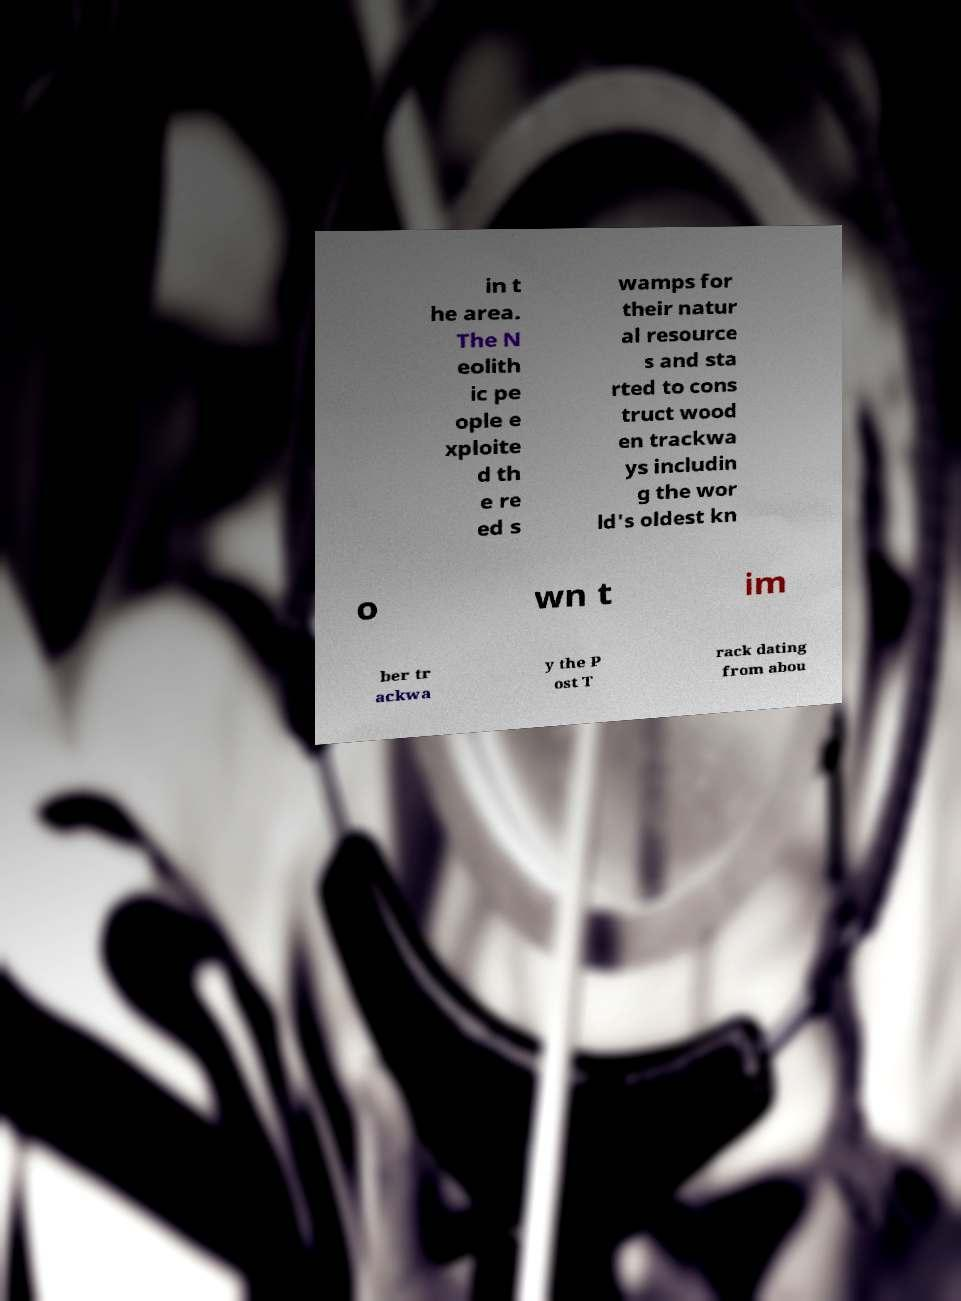Could you extract and type out the text from this image? in t he area. The N eolith ic pe ople e xploite d th e re ed s wamps for their natur al resource s and sta rted to cons truct wood en trackwa ys includin g the wor ld's oldest kn o wn t im ber tr ackwa y the P ost T rack dating from abou 